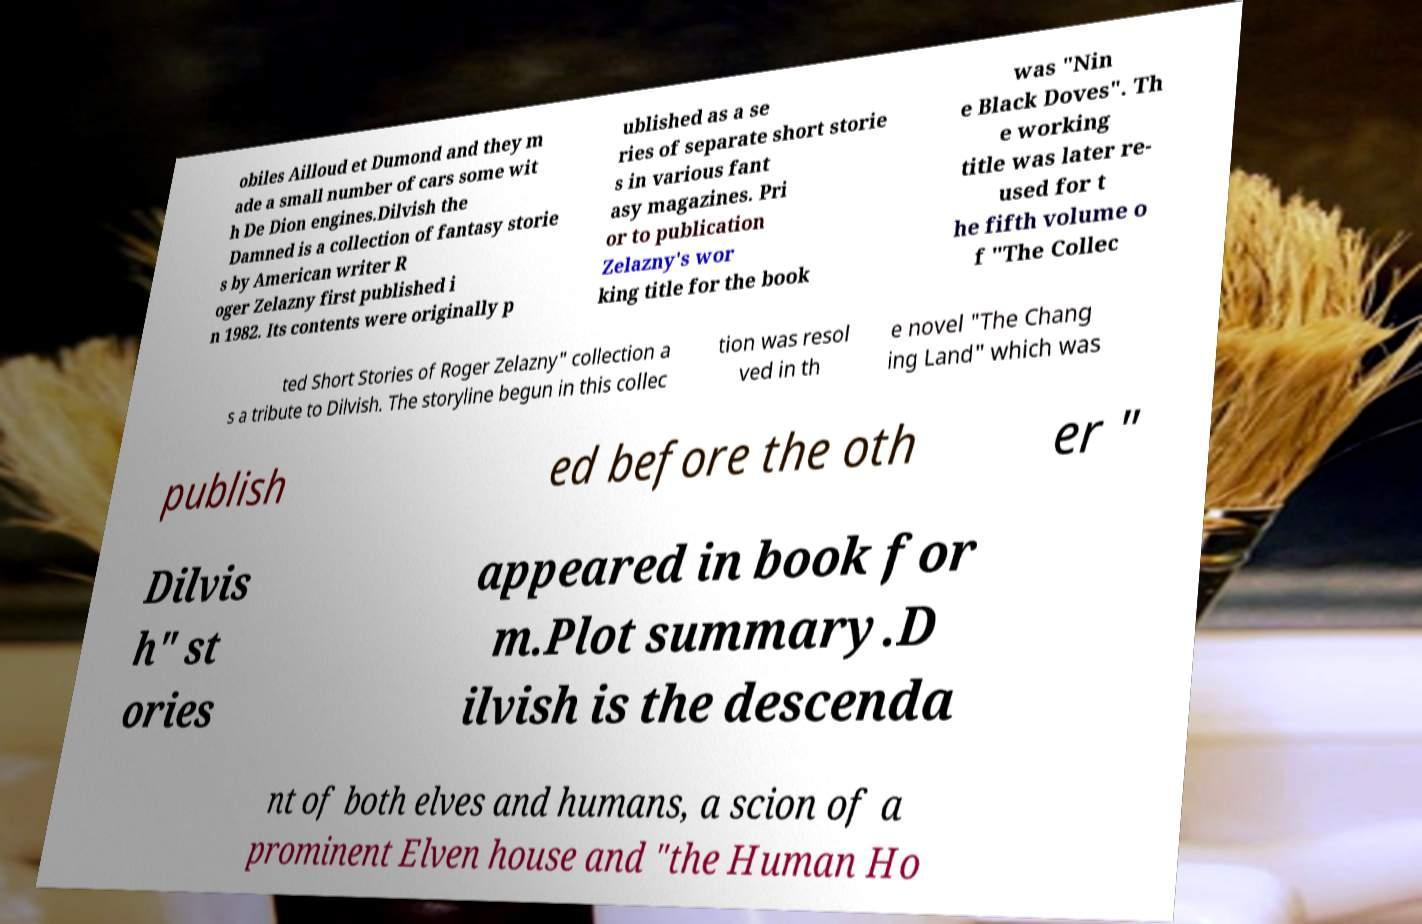What messages or text are displayed in this image? I need them in a readable, typed format. obiles Ailloud et Dumond and they m ade a small number of cars some wit h De Dion engines.Dilvish the Damned is a collection of fantasy storie s by American writer R oger Zelazny first published i n 1982. Its contents were originally p ublished as a se ries of separate short storie s in various fant asy magazines. Pri or to publication Zelazny's wor king title for the book was "Nin e Black Doves". Th e working title was later re- used for t he fifth volume o f "The Collec ted Short Stories of Roger Zelazny" collection a s a tribute to Dilvish. The storyline begun in this collec tion was resol ved in th e novel "The Chang ing Land" which was publish ed before the oth er " Dilvis h" st ories appeared in book for m.Plot summary.D ilvish is the descenda nt of both elves and humans, a scion of a prominent Elven house and "the Human Ho 